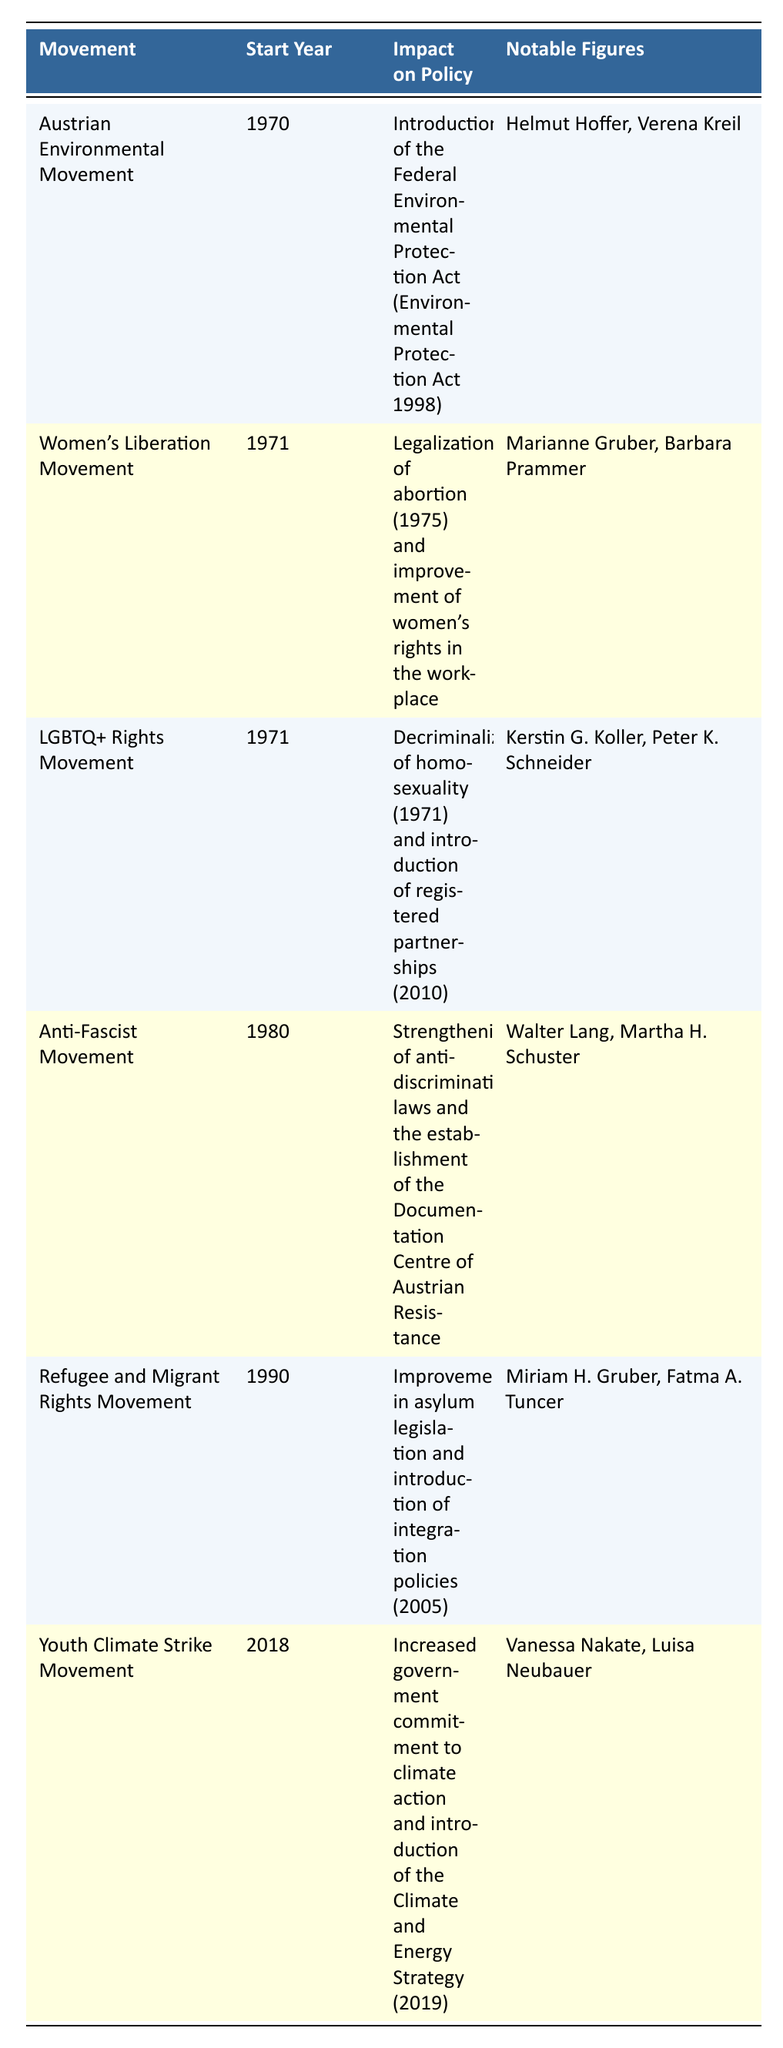What is the impact of the Austrian Environmental Movement on policy? The table states that the impact of the Austrian Environmental Movement is the introduction of the Federal Environmental Protection Act (Environmental Protection Act 1998).
Answer: Introduction of the Federal Environmental Protection Act Which movement started in 1971? There are two movements listed in the table that started in 1971: the Women's Liberation Movement and the LGBTQ+ Rights Movement.
Answer: Women's Liberation Movement and LGBTQ+ Rights Movement How many notable figures are associated with the Refugee and Migrant Rights Movement? The table indicates that there are two notable figures associated with the Refugee and Migrant Rights Movement: Miriam H. Gruber and Fatma A. Tuncer.
Answer: Two notable figures Did the LGBTQ+ Rights Movement contribute to the decriminalization of homosexuality? According to the table, the LGBTQ+ Rights Movement's impact on policy includes the decriminalization of homosexuality in 1971, which confirms the contribution.
Answer: Yes What is the range of start years for the movements listed in the table? The earliest start year is 1970 (for the Austrian Environmental Movement) and the latest is 2018 (for the Youth Climate Strike Movement). The range is calculated as 2018 - 1970 = 48 years.
Answer: 48 years List all the notable figures for the Anti-Fascist Movement. The table lists Walter Lang and Martha H. Schuster as the notable figures associated with the Anti-Fascist Movement.
Answer: Walter Lang, Martha H. Schuster Which movement has the greatest number of associated events? From the table, the Refugee and Migrant Rights Movement has two associated events mentioned, as do several other movements. However, every movement except for the Youth Climate Strike Movement has two events, while the Youth Climate Strike has only one.
Answer: None Compare the policy impacts of the Women’s Liberation Movement and the Anti-Fascist Movement. The Women's Liberation Movement led to the legalization of abortion and improvement of women’s rights in the workplace, while the Anti-Fascist Movement contributed to strengthening anti-discrimination laws and the establishment of a documentation center. This comparison shows that both movements had significant impacts but focused on different aspects of rights and protections.
Answer: Different focuses on rights and protections What year did the Youth Climate Strike Movement start? The table clearly indicates that the Youth Climate Strike Movement started in 2018.
Answer: 2018 Which social movement had an impact on asylum legislation? According to the table, the Refugee and Migrant Rights Movement had an impact on asylum legislation, specifically improvement in asylum legislation and the introduction of integration policies in 2005.
Answer: Refugee and Migrant Rights Movement 